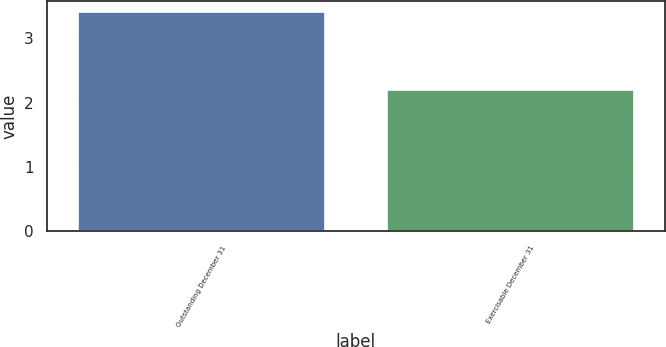Convert chart. <chart><loc_0><loc_0><loc_500><loc_500><bar_chart><fcel>Outstanding December 31<fcel>Exercisable December 31<nl><fcel>3.4<fcel>2.2<nl></chart> 